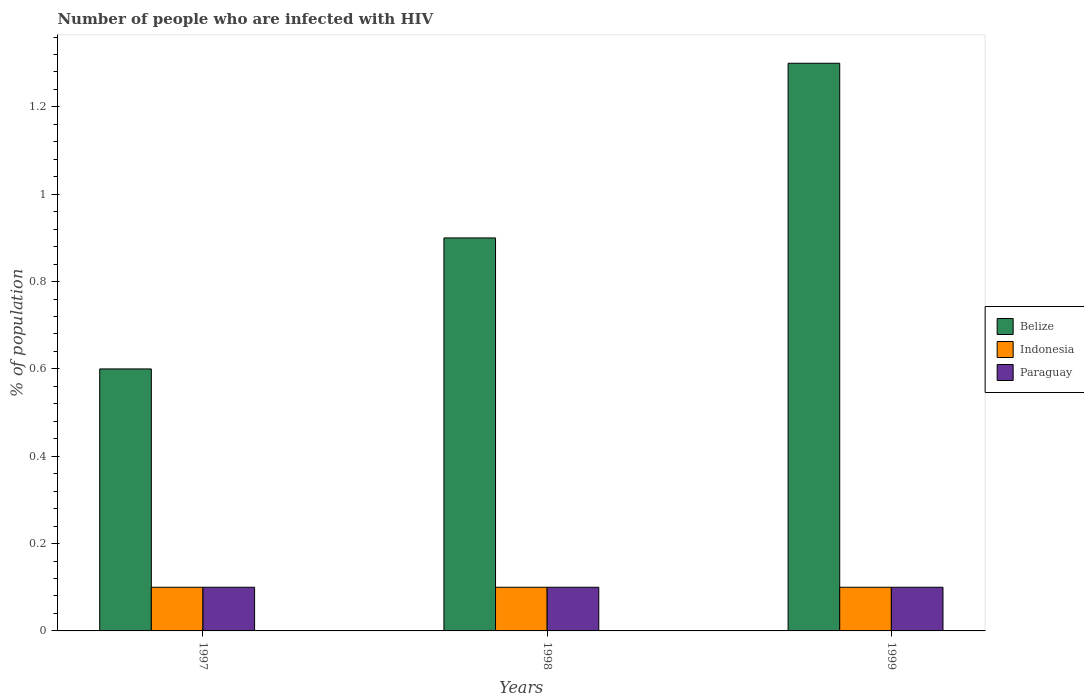Are the number of bars on each tick of the X-axis equal?
Give a very brief answer. Yes. How many bars are there on the 2nd tick from the left?
Keep it short and to the point. 3. How many bars are there on the 1st tick from the right?
Provide a short and direct response. 3. In how many cases, is the number of bars for a given year not equal to the number of legend labels?
Your answer should be compact. 0. Across all years, what is the maximum percentage of HIV infected population in in Paraguay?
Keep it short and to the point. 0.1. In which year was the percentage of HIV infected population in in Paraguay minimum?
Offer a very short reply. 1997. What is the total percentage of HIV infected population in in Indonesia in the graph?
Keep it short and to the point. 0.3. What is the difference between the percentage of HIV infected population in in Belize in 1997 and that in 1998?
Ensure brevity in your answer.  -0.3. What is the average percentage of HIV infected population in in Indonesia per year?
Provide a short and direct response. 0.1. In how many years, is the percentage of HIV infected population in in Indonesia greater than 0.24000000000000002 %?
Keep it short and to the point. 0. What is the ratio of the percentage of HIV infected population in in Belize in 1997 to that in 1999?
Offer a terse response. 0.46. Is the percentage of HIV infected population in in Indonesia in 1997 less than that in 1999?
Your response must be concise. No. Is the difference between the percentage of HIV infected population in in Paraguay in 1997 and 1998 greater than the difference between the percentage of HIV infected population in in Indonesia in 1997 and 1998?
Your answer should be very brief. No. What is the difference between the highest and the second highest percentage of HIV infected population in in Paraguay?
Offer a very short reply. 0. In how many years, is the percentage of HIV infected population in in Indonesia greater than the average percentage of HIV infected population in in Indonesia taken over all years?
Your response must be concise. 0. Is the sum of the percentage of HIV infected population in in Belize in 1997 and 1999 greater than the maximum percentage of HIV infected population in in Indonesia across all years?
Provide a succinct answer. Yes. What does the 3rd bar from the right in 1998 represents?
Offer a terse response. Belize. Is it the case that in every year, the sum of the percentage of HIV infected population in in Paraguay and percentage of HIV infected population in in Indonesia is greater than the percentage of HIV infected population in in Belize?
Keep it short and to the point. No. Are all the bars in the graph horizontal?
Your answer should be compact. No. What is the difference between two consecutive major ticks on the Y-axis?
Your answer should be compact. 0.2. Does the graph contain any zero values?
Offer a very short reply. No. Does the graph contain grids?
Provide a succinct answer. No. How many legend labels are there?
Keep it short and to the point. 3. How are the legend labels stacked?
Provide a short and direct response. Vertical. What is the title of the graph?
Offer a terse response. Number of people who are infected with HIV. Does "Least developed countries" appear as one of the legend labels in the graph?
Offer a terse response. No. What is the label or title of the Y-axis?
Provide a succinct answer. % of population. What is the % of population of Paraguay in 1998?
Offer a terse response. 0.1. What is the % of population of Paraguay in 1999?
Ensure brevity in your answer.  0.1. Across all years, what is the maximum % of population of Belize?
Your answer should be very brief. 1.3. Across all years, what is the maximum % of population of Indonesia?
Offer a terse response. 0.1. Across all years, what is the minimum % of population in Belize?
Make the answer very short. 0.6. Across all years, what is the minimum % of population in Paraguay?
Provide a succinct answer. 0.1. What is the total % of population of Belize in the graph?
Your answer should be compact. 2.8. What is the total % of population in Indonesia in the graph?
Keep it short and to the point. 0.3. What is the difference between the % of population of Paraguay in 1997 and that in 1998?
Provide a succinct answer. 0. What is the difference between the % of population of Paraguay in 1998 and that in 1999?
Provide a short and direct response. 0. What is the difference between the % of population in Belize in 1997 and the % of population in Indonesia in 1998?
Ensure brevity in your answer.  0.5. What is the difference between the % of population in Belize in 1997 and the % of population in Paraguay in 1998?
Make the answer very short. 0.5. What is the difference between the % of population in Indonesia in 1997 and the % of population in Paraguay in 1998?
Your response must be concise. 0. What is the difference between the % of population of Belize in 1997 and the % of population of Indonesia in 1999?
Give a very brief answer. 0.5. What is the difference between the % of population in Belize in 1997 and the % of population in Paraguay in 1999?
Ensure brevity in your answer.  0.5. What is the difference between the % of population of Indonesia in 1997 and the % of population of Paraguay in 1999?
Ensure brevity in your answer.  0. What is the difference between the % of population of Belize in 1998 and the % of population of Indonesia in 1999?
Offer a very short reply. 0.8. What is the difference between the % of population in Belize in 1998 and the % of population in Paraguay in 1999?
Offer a terse response. 0.8. What is the average % of population in Indonesia per year?
Provide a succinct answer. 0.1. In the year 1997, what is the difference between the % of population in Belize and % of population in Indonesia?
Offer a very short reply. 0.5. In the year 1997, what is the difference between the % of population in Belize and % of population in Paraguay?
Your answer should be very brief. 0.5. In the year 1997, what is the difference between the % of population of Indonesia and % of population of Paraguay?
Ensure brevity in your answer.  0. In the year 1998, what is the difference between the % of population of Belize and % of population of Paraguay?
Provide a short and direct response. 0.8. In the year 1998, what is the difference between the % of population of Indonesia and % of population of Paraguay?
Keep it short and to the point. 0. In the year 1999, what is the difference between the % of population in Belize and % of population in Indonesia?
Your response must be concise. 1.2. In the year 1999, what is the difference between the % of population of Indonesia and % of population of Paraguay?
Provide a succinct answer. 0. What is the ratio of the % of population of Belize in 1997 to that in 1998?
Provide a succinct answer. 0.67. What is the ratio of the % of population in Paraguay in 1997 to that in 1998?
Your response must be concise. 1. What is the ratio of the % of population in Belize in 1997 to that in 1999?
Offer a terse response. 0.46. What is the ratio of the % of population of Indonesia in 1997 to that in 1999?
Offer a very short reply. 1. What is the ratio of the % of population of Paraguay in 1997 to that in 1999?
Your response must be concise. 1. What is the ratio of the % of population in Belize in 1998 to that in 1999?
Offer a terse response. 0.69. What is the ratio of the % of population of Indonesia in 1998 to that in 1999?
Provide a short and direct response. 1. What is the ratio of the % of population of Paraguay in 1998 to that in 1999?
Provide a short and direct response. 1. What is the difference between the highest and the second highest % of population in Belize?
Your answer should be compact. 0.4. What is the difference between the highest and the lowest % of population in Belize?
Your answer should be very brief. 0.7. 